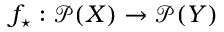Convert formula to latex. <formula><loc_0><loc_0><loc_500><loc_500>f _ { ^ { * } } \colon { \mathcal { P } } ( X ) \rightarrow { \mathcal { P } } ( Y )</formula> 